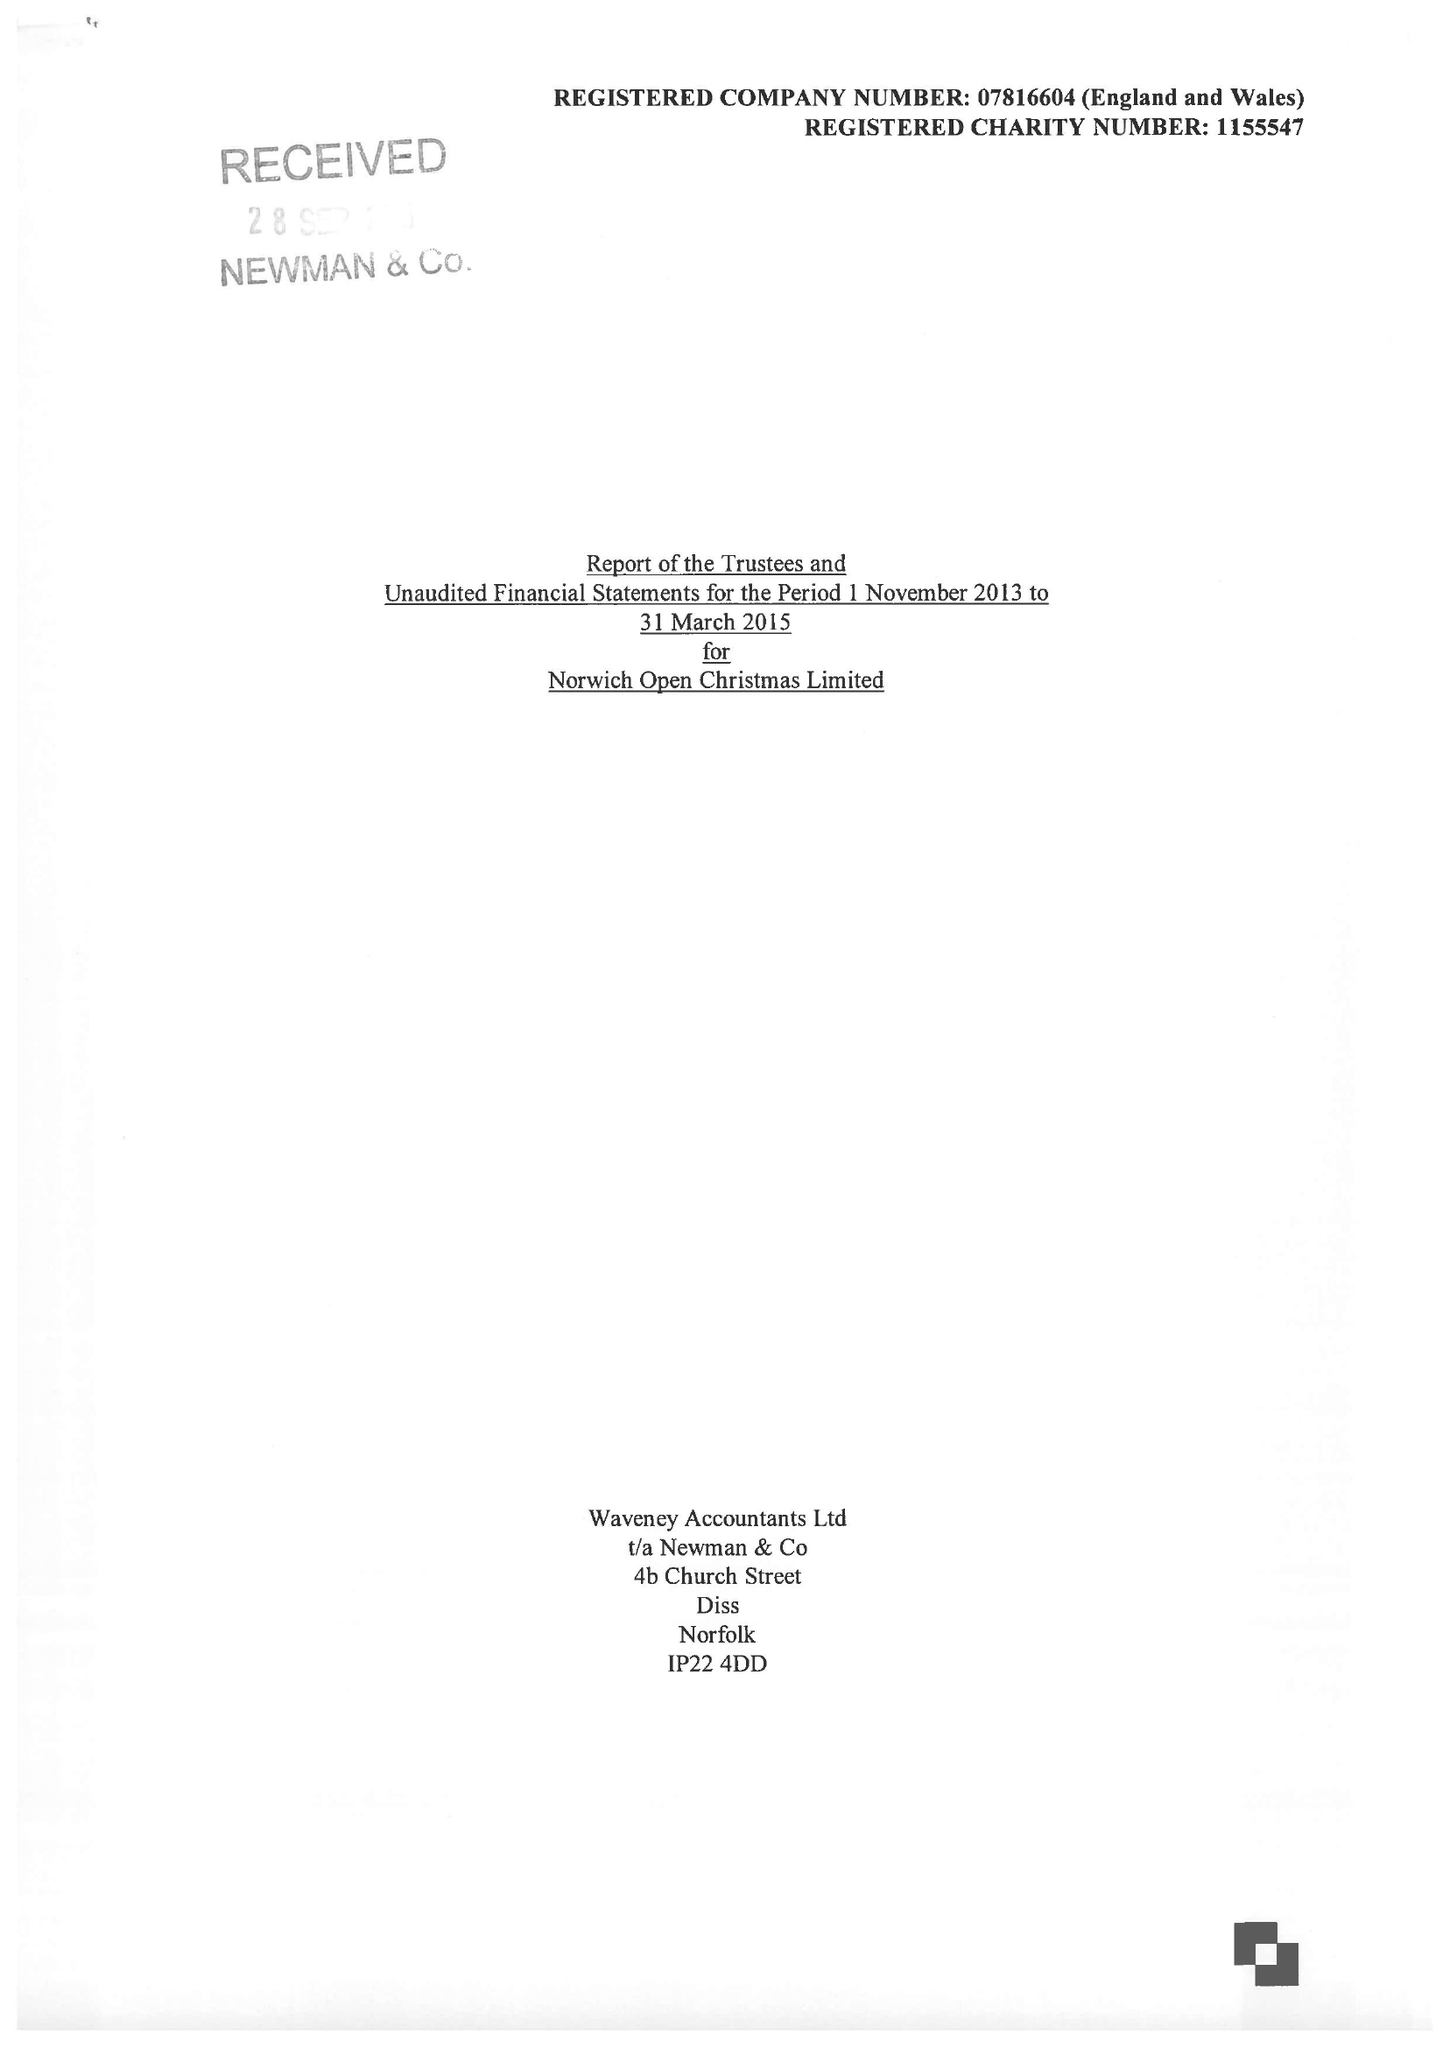What is the value for the charity_name?
Answer the question using a single word or phrase. Norwich Open Christmas Ltd. 